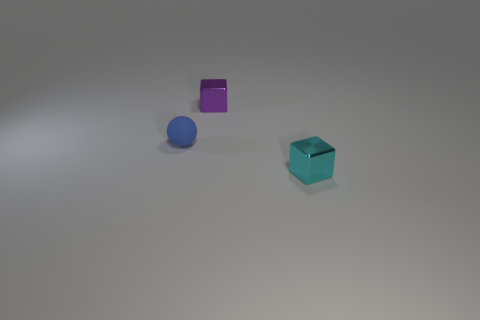Add 3 blue blocks. How many objects exist? 6 Subtract all cubes. How many objects are left? 1 Subtract 1 blue balls. How many objects are left? 2 Subtract all cyan blocks. Subtract all cyan spheres. How many blocks are left? 1 Subtract all yellow matte cylinders. Subtract all purple shiny blocks. How many objects are left? 2 Add 3 tiny blue rubber objects. How many tiny blue rubber objects are left? 4 Add 2 tiny matte objects. How many tiny matte objects exist? 3 